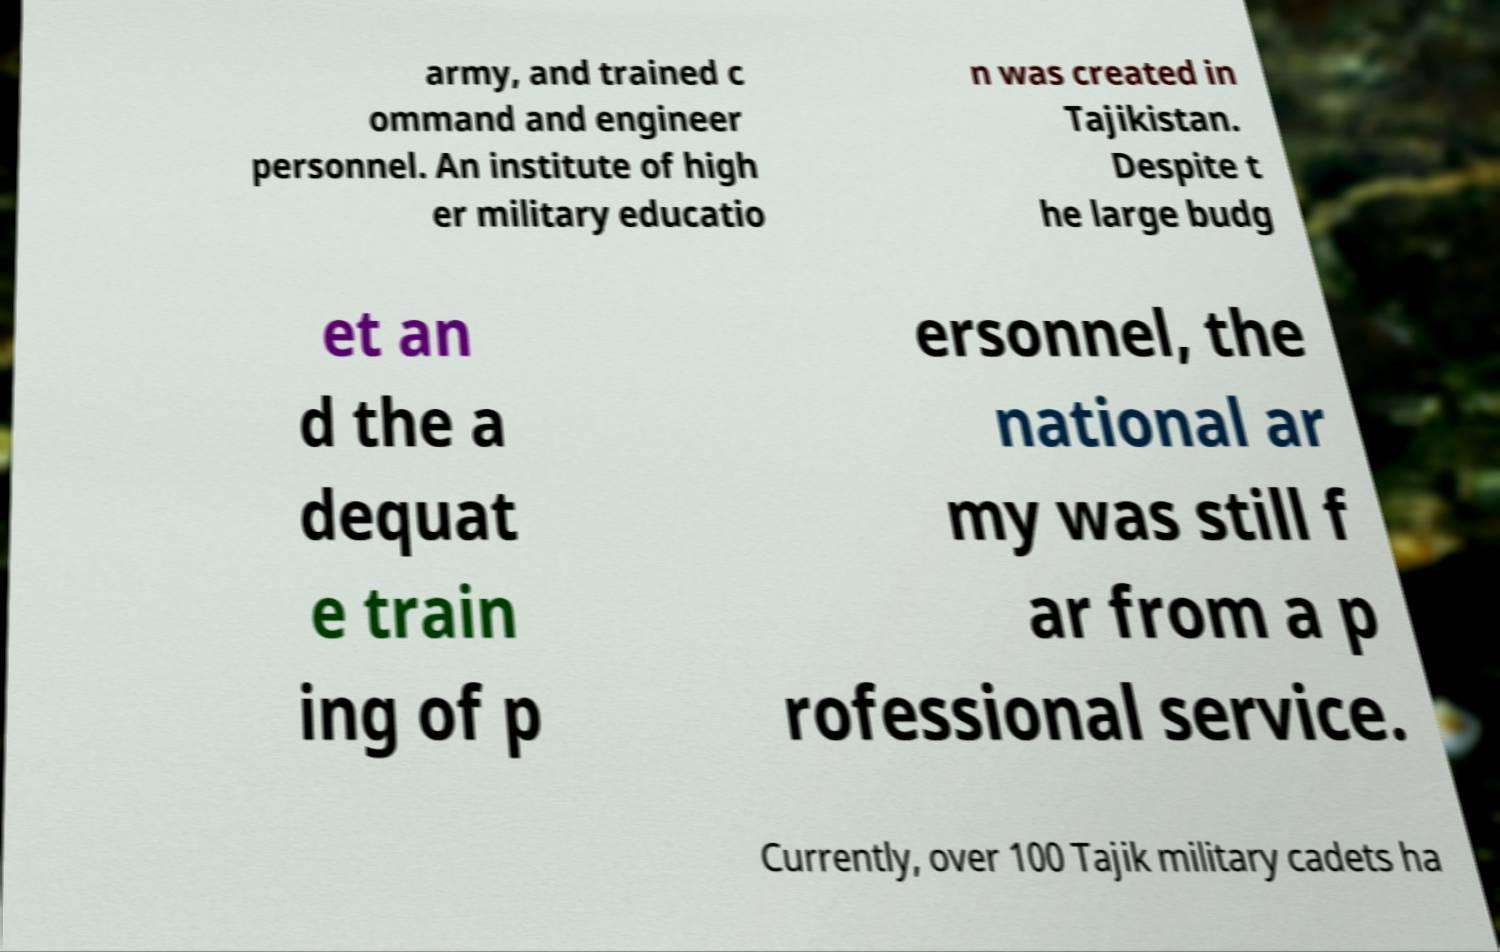Could you assist in decoding the text presented in this image and type it out clearly? army, and trained c ommand and engineer personnel. An institute of high er military educatio n was created in Tajikistan. Despite t he large budg et an d the a dequat e train ing of p ersonnel, the national ar my was still f ar from a p rofessional service. Currently, over 100 Tajik military cadets ha 